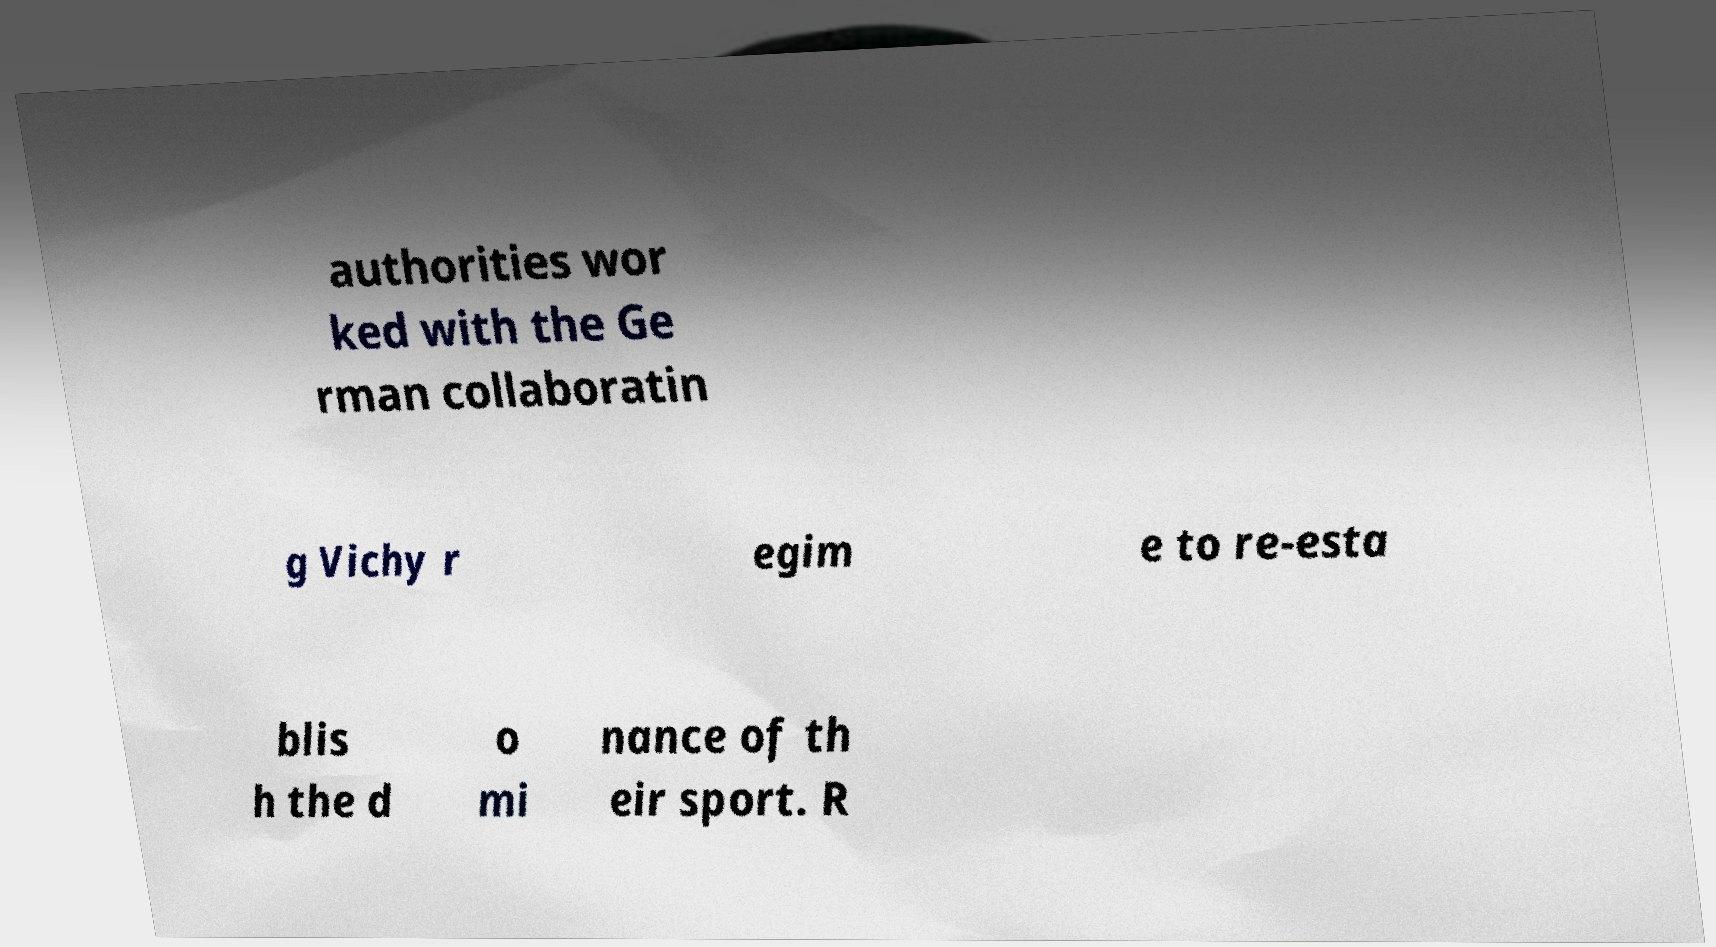Please identify and transcribe the text found in this image. authorities wor ked with the Ge rman collaboratin g Vichy r egim e to re-esta blis h the d o mi nance of th eir sport. R 